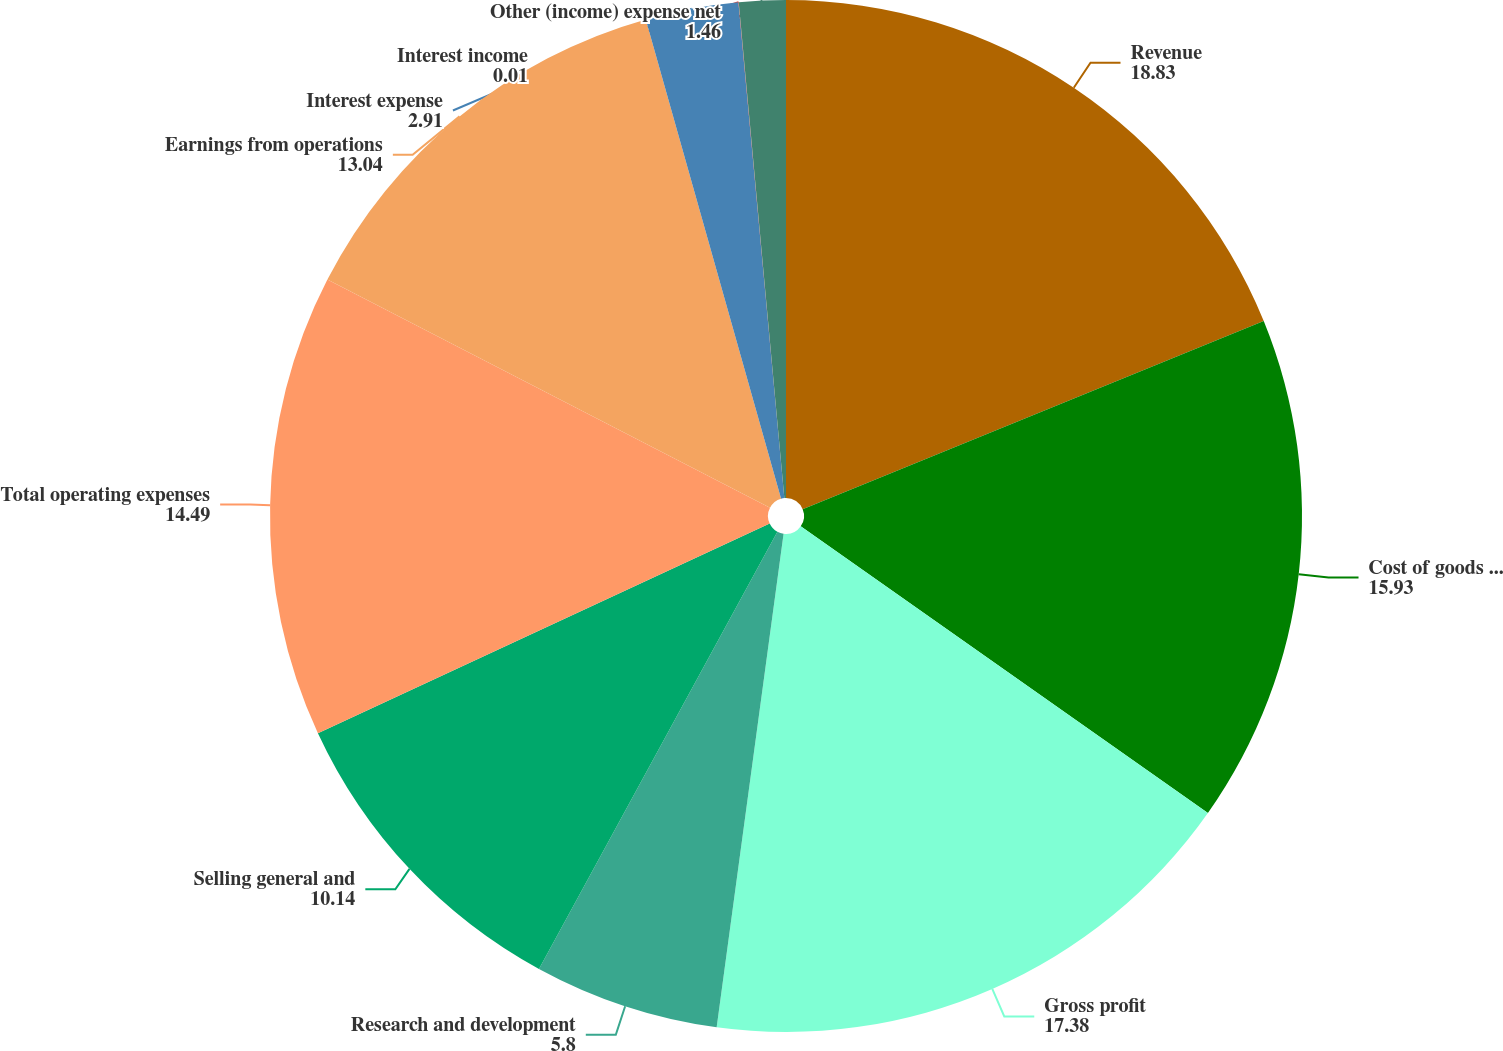Convert chart to OTSL. <chart><loc_0><loc_0><loc_500><loc_500><pie_chart><fcel>Revenue<fcel>Cost of goods sold<fcel>Gross profit<fcel>Research and development<fcel>Selling general and<fcel>Total operating expenses<fcel>Earnings from operations<fcel>Interest expense<fcel>Interest income<fcel>Other (income) expense net<nl><fcel>18.83%<fcel>15.93%<fcel>17.38%<fcel>5.8%<fcel>10.14%<fcel>14.49%<fcel>13.04%<fcel>2.91%<fcel>0.01%<fcel>1.46%<nl></chart> 